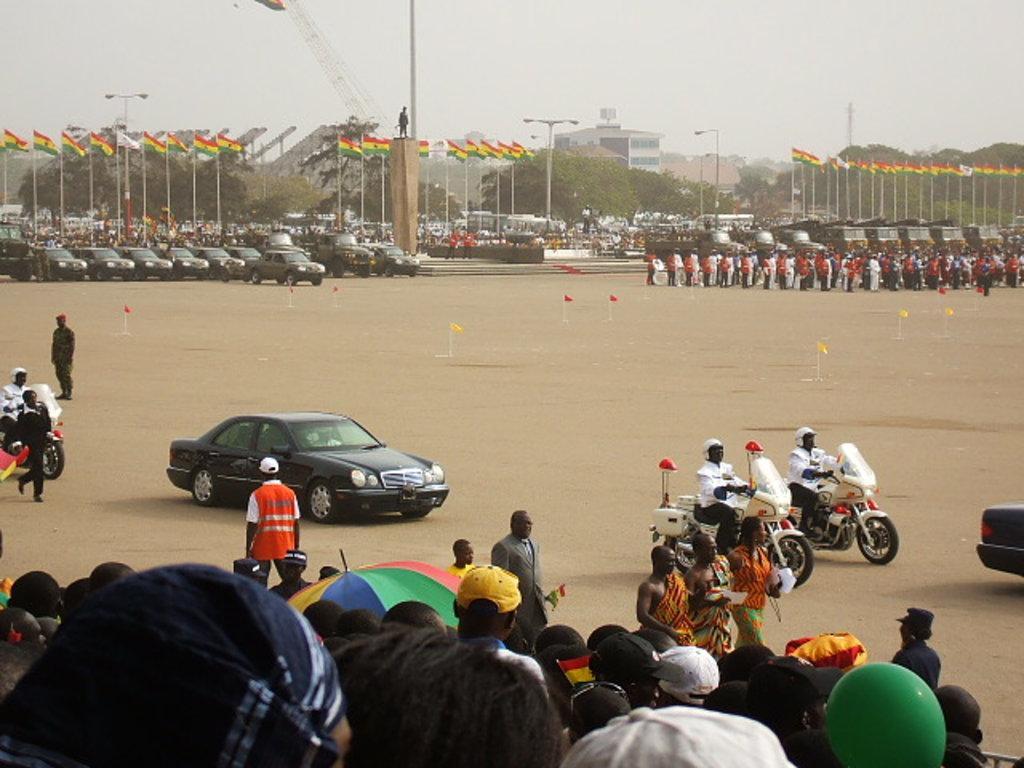Could you give a brief overview of what you see in this image? Front of the image we can see people, umbrella, vehicles and flag. Background we can see flags, buildings, light poles, trees, people, sky, statue and vehicles. 